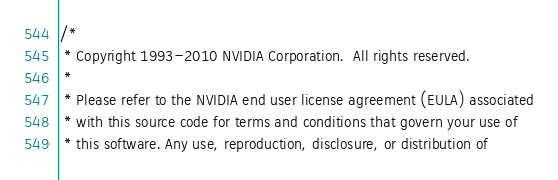<code> <loc_0><loc_0><loc_500><loc_500><_Cuda_>/*
 * Copyright 1993-2010 NVIDIA Corporation.  All rights reserved.
 *
 * Please refer to the NVIDIA end user license agreement (EULA) associated
 * with this source code for terms and conditions that govern your use of
 * this software. Any use, reproduction, disclosure, or distribution of</code> 